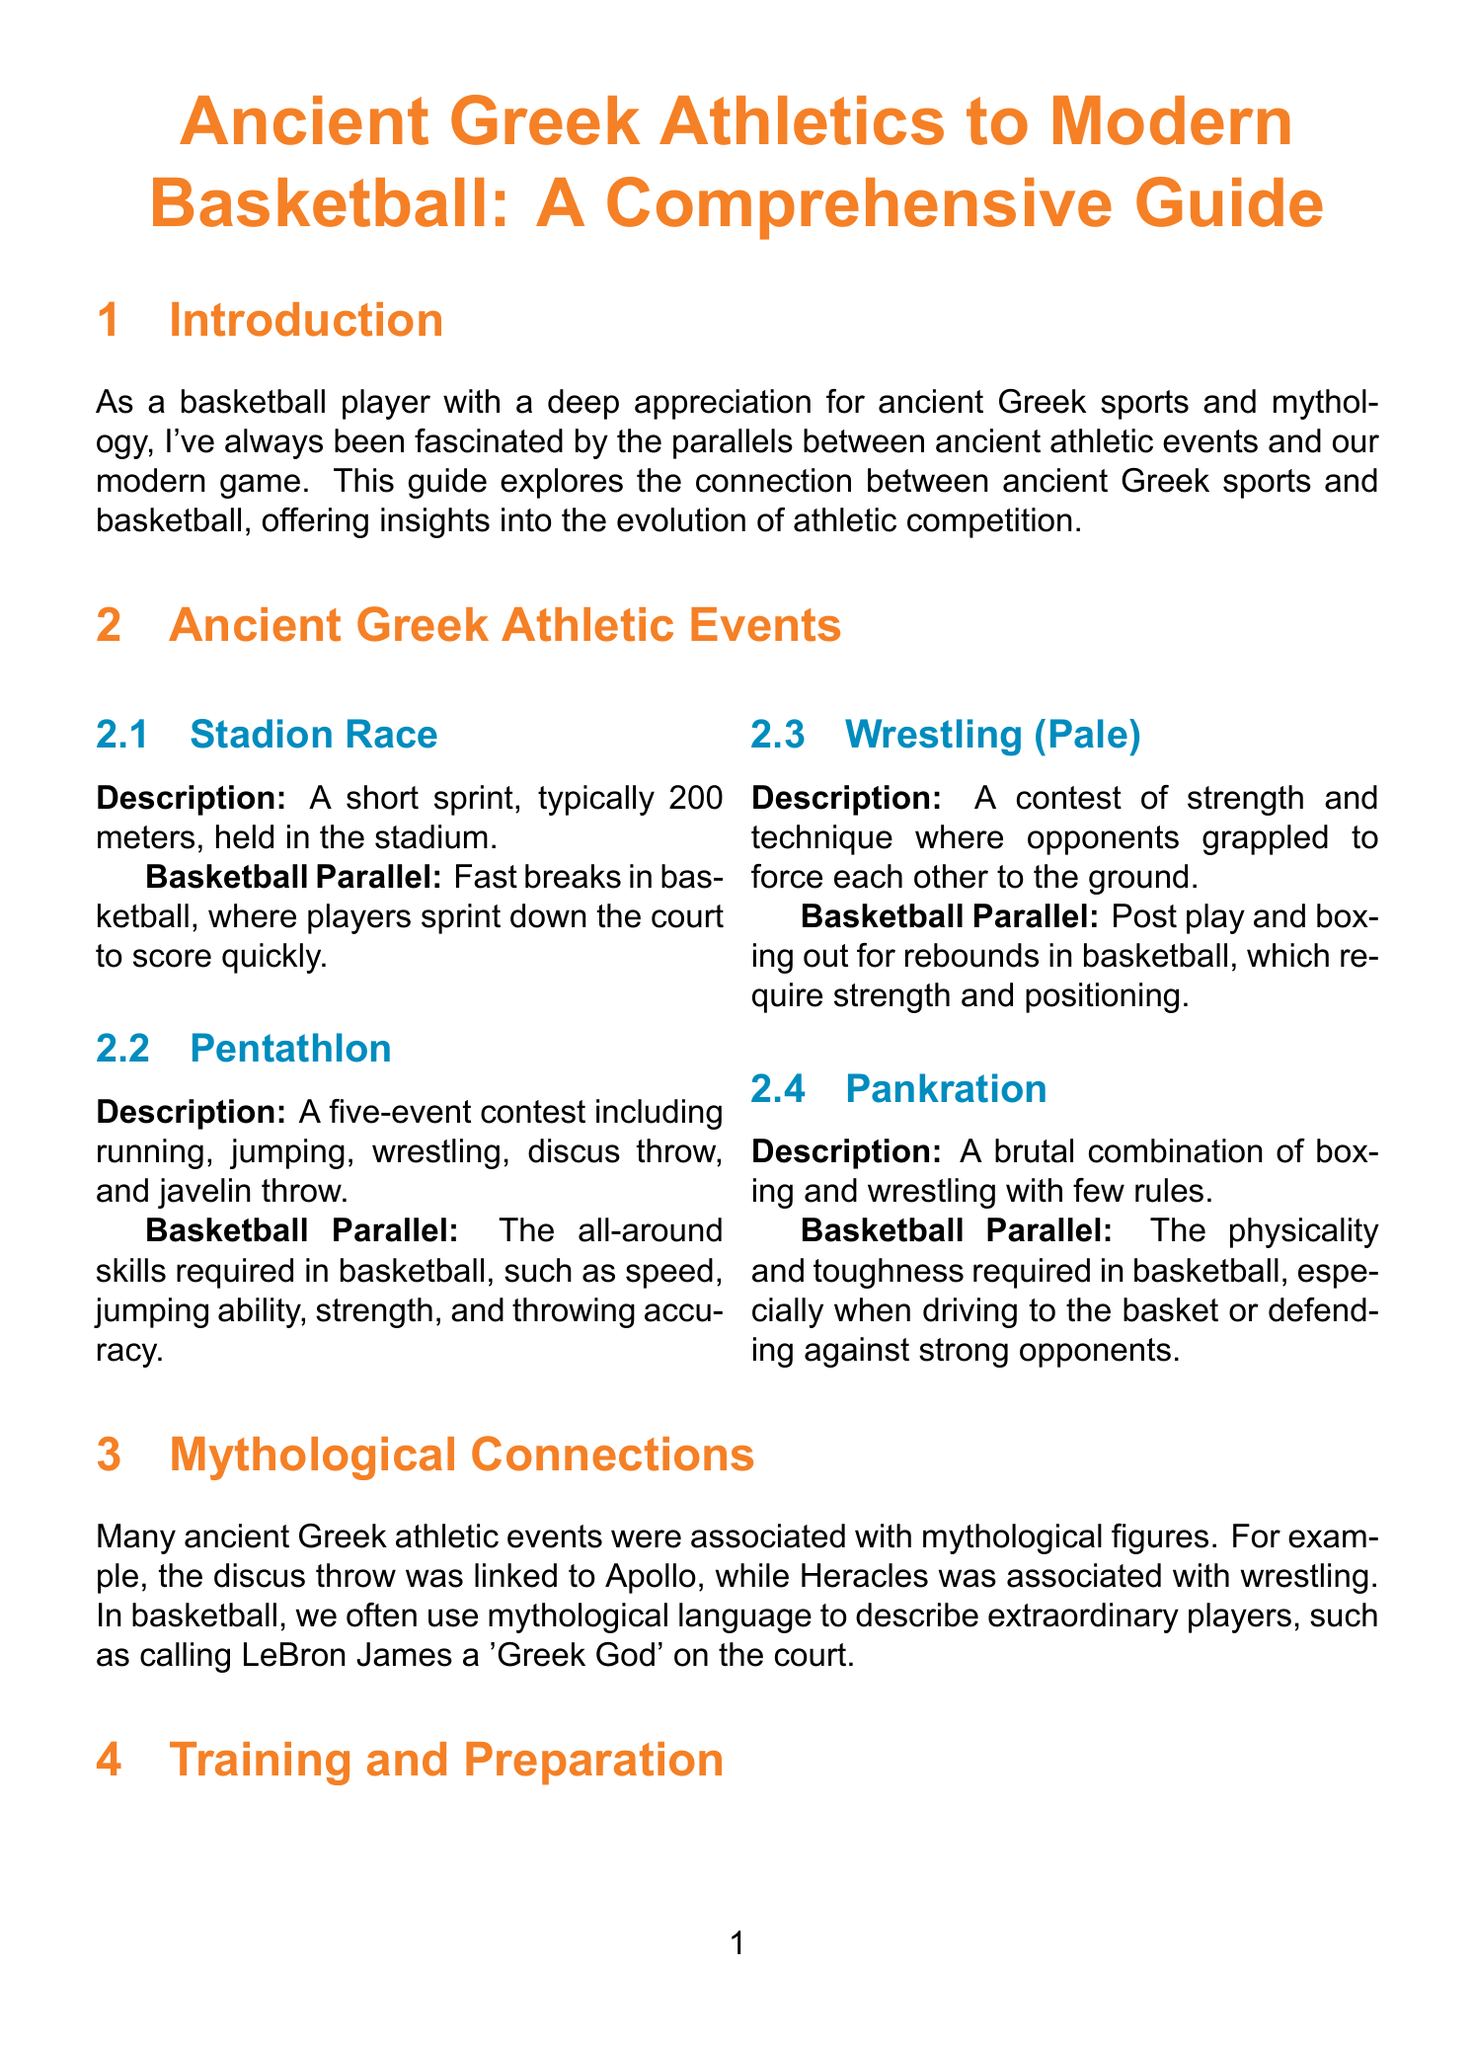What is the title of the guide? The title of the guide is stated in the document's header.
Answer: Ancient Greek Athletics to Modern Basketball: A Comprehensive Guide What is the distance of the Stadion Race? The document specifies the length of the Stadion Race.
Answer: 200 meters Name one ancient Greek athletic event that requires strength and technique. The document lists wrestling as a contest of strength and technique.
Answer: Wrestling (Pale) What is the modern basketball parallel of the Pentathlon? The guide describes the all-around skills needed in basketball as the modern counterpart.
Answer: The all-around skills required in basketball What does the Olive Wreath symbolize? The document explains the meaning of the prize awarded at the ancient Olympic Games.
Answer: Glory and honor What type of facilities were used for training in ancient Greece? The guide provides information about the training facilities for athletes in ancient Greece.
Answer: Gymnasion How often were the Ancient Olympic Games held? The document mentions the frequency of the Ancient Olympic Games.
Answer: Every four years Which mythological figure is associated with wrestling? The guide links a specific figure to the sport of wrestling.
Answer: Heracles 